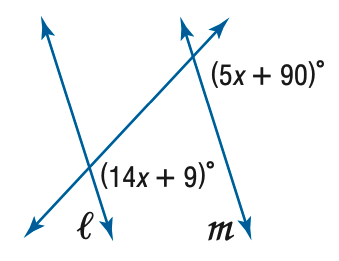Question: Find x so that m \parallel n.
Choices:
A. 9
B. 10
C. 11
D. 12
Answer with the letter. Answer: A 